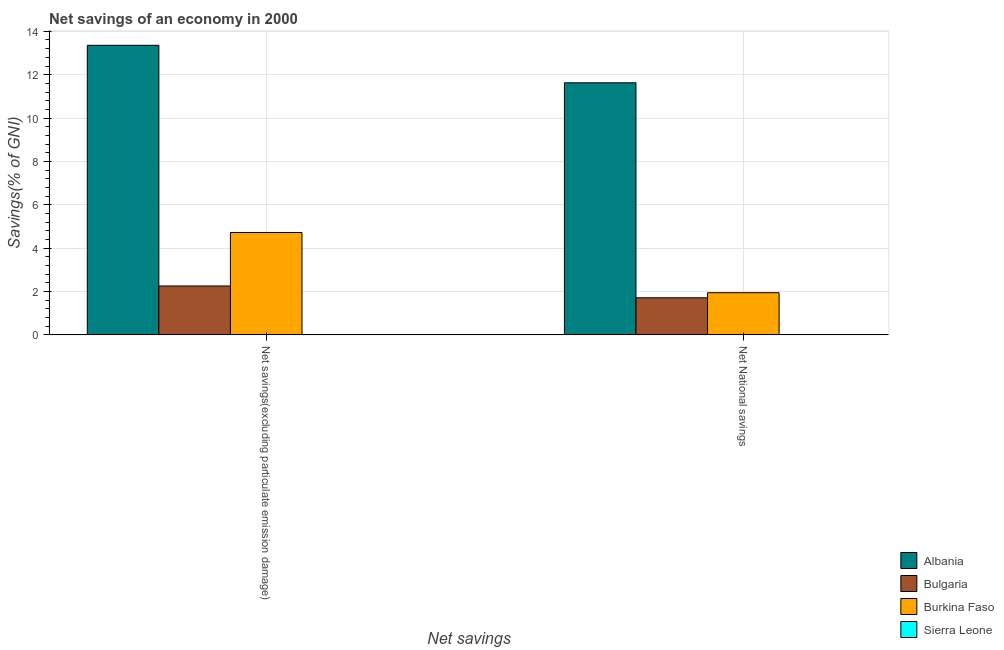How many different coloured bars are there?
Your response must be concise. 3. How many groups of bars are there?
Make the answer very short. 2. Are the number of bars per tick equal to the number of legend labels?
Your response must be concise. No. How many bars are there on the 1st tick from the right?
Offer a terse response. 3. What is the label of the 2nd group of bars from the left?
Make the answer very short. Net National savings. What is the net national savings in Burkina Faso?
Provide a short and direct response. 1.95. Across all countries, what is the maximum net savings(excluding particulate emission damage)?
Your answer should be very brief. 13.35. In which country was the net national savings maximum?
Give a very brief answer. Albania. What is the total net savings(excluding particulate emission damage) in the graph?
Provide a succinct answer. 20.33. What is the difference between the net savings(excluding particulate emission damage) in Bulgaria and that in Albania?
Make the answer very short. -11.1. What is the difference between the net savings(excluding particulate emission damage) in Burkina Faso and the net national savings in Albania?
Make the answer very short. -6.9. What is the average net national savings per country?
Your answer should be very brief. 3.82. What is the difference between the net national savings and net savings(excluding particulate emission damage) in Bulgaria?
Provide a succinct answer. -0.54. In how many countries, is the net savings(excluding particulate emission damage) greater than 12 %?
Make the answer very short. 1. What is the ratio of the net savings(excluding particulate emission damage) in Albania to that in Bulgaria?
Your answer should be very brief. 5.92. Is the net savings(excluding particulate emission damage) in Burkina Faso less than that in Bulgaria?
Your answer should be very brief. No. In how many countries, is the net savings(excluding particulate emission damage) greater than the average net savings(excluding particulate emission damage) taken over all countries?
Offer a very short reply. 1. Are all the bars in the graph horizontal?
Give a very brief answer. No. Does the graph contain any zero values?
Your answer should be compact. Yes. How many legend labels are there?
Make the answer very short. 4. What is the title of the graph?
Keep it short and to the point. Net savings of an economy in 2000. Does "Antigua and Barbuda" appear as one of the legend labels in the graph?
Provide a short and direct response. No. What is the label or title of the X-axis?
Make the answer very short. Net savings. What is the label or title of the Y-axis?
Your response must be concise. Savings(% of GNI). What is the Savings(% of GNI) of Albania in Net savings(excluding particulate emission damage)?
Provide a succinct answer. 13.35. What is the Savings(% of GNI) in Bulgaria in Net savings(excluding particulate emission damage)?
Offer a terse response. 2.26. What is the Savings(% of GNI) in Burkina Faso in Net savings(excluding particulate emission damage)?
Your response must be concise. 4.72. What is the Savings(% of GNI) in Sierra Leone in Net savings(excluding particulate emission damage)?
Offer a very short reply. 0. What is the Savings(% of GNI) of Albania in Net National savings?
Your answer should be compact. 11.63. What is the Savings(% of GNI) in Bulgaria in Net National savings?
Your answer should be very brief. 1.71. What is the Savings(% of GNI) of Burkina Faso in Net National savings?
Give a very brief answer. 1.95. What is the Savings(% of GNI) of Sierra Leone in Net National savings?
Provide a succinct answer. 0. Across all Net savings, what is the maximum Savings(% of GNI) in Albania?
Provide a succinct answer. 13.35. Across all Net savings, what is the maximum Savings(% of GNI) in Bulgaria?
Offer a terse response. 2.26. Across all Net savings, what is the maximum Savings(% of GNI) in Burkina Faso?
Offer a very short reply. 4.72. Across all Net savings, what is the minimum Savings(% of GNI) of Albania?
Keep it short and to the point. 11.63. Across all Net savings, what is the minimum Savings(% of GNI) in Bulgaria?
Provide a succinct answer. 1.71. Across all Net savings, what is the minimum Savings(% of GNI) in Burkina Faso?
Make the answer very short. 1.95. What is the total Savings(% of GNI) of Albania in the graph?
Ensure brevity in your answer.  24.98. What is the total Savings(% of GNI) in Bulgaria in the graph?
Provide a succinct answer. 3.97. What is the total Savings(% of GNI) in Burkina Faso in the graph?
Your response must be concise. 6.67. What is the difference between the Savings(% of GNI) of Albania in Net savings(excluding particulate emission damage) and that in Net National savings?
Your answer should be very brief. 1.73. What is the difference between the Savings(% of GNI) of Bulgaria in Net savings(excluding particulate emission damage) and that in Net National savings?
Give a very brief answer. 0.54. What is the difference between the Savings(% of GNI) of Burkina Faso in Net savings(excluding particulate emission damage) and that in Net National savings?
Your answer should be compact. 2.78. What is the difference between the Savings(% of GNI) in Albania in Net savings(excluding particulate emission damage) and the Savings(% of GNI) in Bulgaria in Net National savings?
Provide a succinct answer. 11.64. What is the difference between the Savings(% of GNI) in Albania in Net savings(excluding particulate emission damage) and the Savings(% of GNI) in Burkina Faso in Net National savings?
Provide a short and direct response. 11.41. What is the difference between the Savings(% of GNI) of Bulgaria in Net savings(excluding particulate emission damage) and the Savings(% of GNI) of Burkina Faso in Net National savings?
Offer a terse response. 0.31. What is the average Savings(% of GNI) in Albania per Net savings?
Give a very brief answer. 12.49. What is the average Savings(% of GNI) of Bulgaria per Net savings?
Ensure brevity in your answer.  1.98. What is the average Savings(% of GNI) in Burkina Faso per Net savings?
Keep it short and to the point. 3.33. What is the difference between the Savings(% of GNI) in Albania and Savings(% of GNI) in Bulgaria in Net savings(excluding particulate emission damage)?
Offer a very short reply. 11.1. What is the difference between the Savings(% of GNI) in Albania and Savings(% of GNI) in Burkina Faso in Net savings(excluding particulate emission damage)?
Your answer should be very brief. 8.63. What is the difference between the Savings(% of GNI) of Bulgaria and Savings(% of GNI) of Burkina Faso in Net savings(excluding particulate emission damage)?
Your response must be concise. -2.47. What is the difference between the Savings(% of GNI) of Albania and Savings(% of GNI) of Bulgaria in Net National savings?
Provide a succinct answer. 9.91. What is the difference between the Savings(% of GNI) in Albania and Savings(% of GNI) in Burkina Faso in Net National savings?
Your answer should be compact. 9.68. What is the difference between the Savings(% of GNI) in Bulgaria and Savings(% of GNI) in Burkina Faso in Net National savings?
Your response must be concise. -0.23. What is the ratio of the Savings(% of GNI) of Albania in Net savings(excluding particulate emission damage) to that in Net National savings?
Your answer should be very brief. 1.15. What is the ratio of the Savings(% of GNI) of Bulgaria in Net savings(excluding particulate emission damage) to that in Net National savings?
Give a very brief answer. 1.32. What is the ratio of the Savings(% of GNI) in Burkina Faso in Net savings(excluding particulate emission damage) to that in Net National savings?
Give a very brief answer. 2.43. What is the difference between the highest and the second highest Savings(% of GNI) in Albania?
Give a very brief answer. 1.73. What is the difference between the highest and the second highest Savings(% of GNI) of Bulgaria?
Your answer should be compact. 0.54. What is the difference between the highest and the second highest Savings(% of GNI) in Burkina Faso?
Your response must be concise. 2.78. What is the difference between the highest and the lowest Savings(% of GNI) of Albania?
Offer a terse response. 1.73. What is the difference between the highest and the lowest Savings(% of GNI) of Bulgaria?
Offer a very short reply. 0.54. What is the difference between the highest and the lowest Savings(% of GNI) in Burkina Faso?
Your response must be concise. 2.78. 